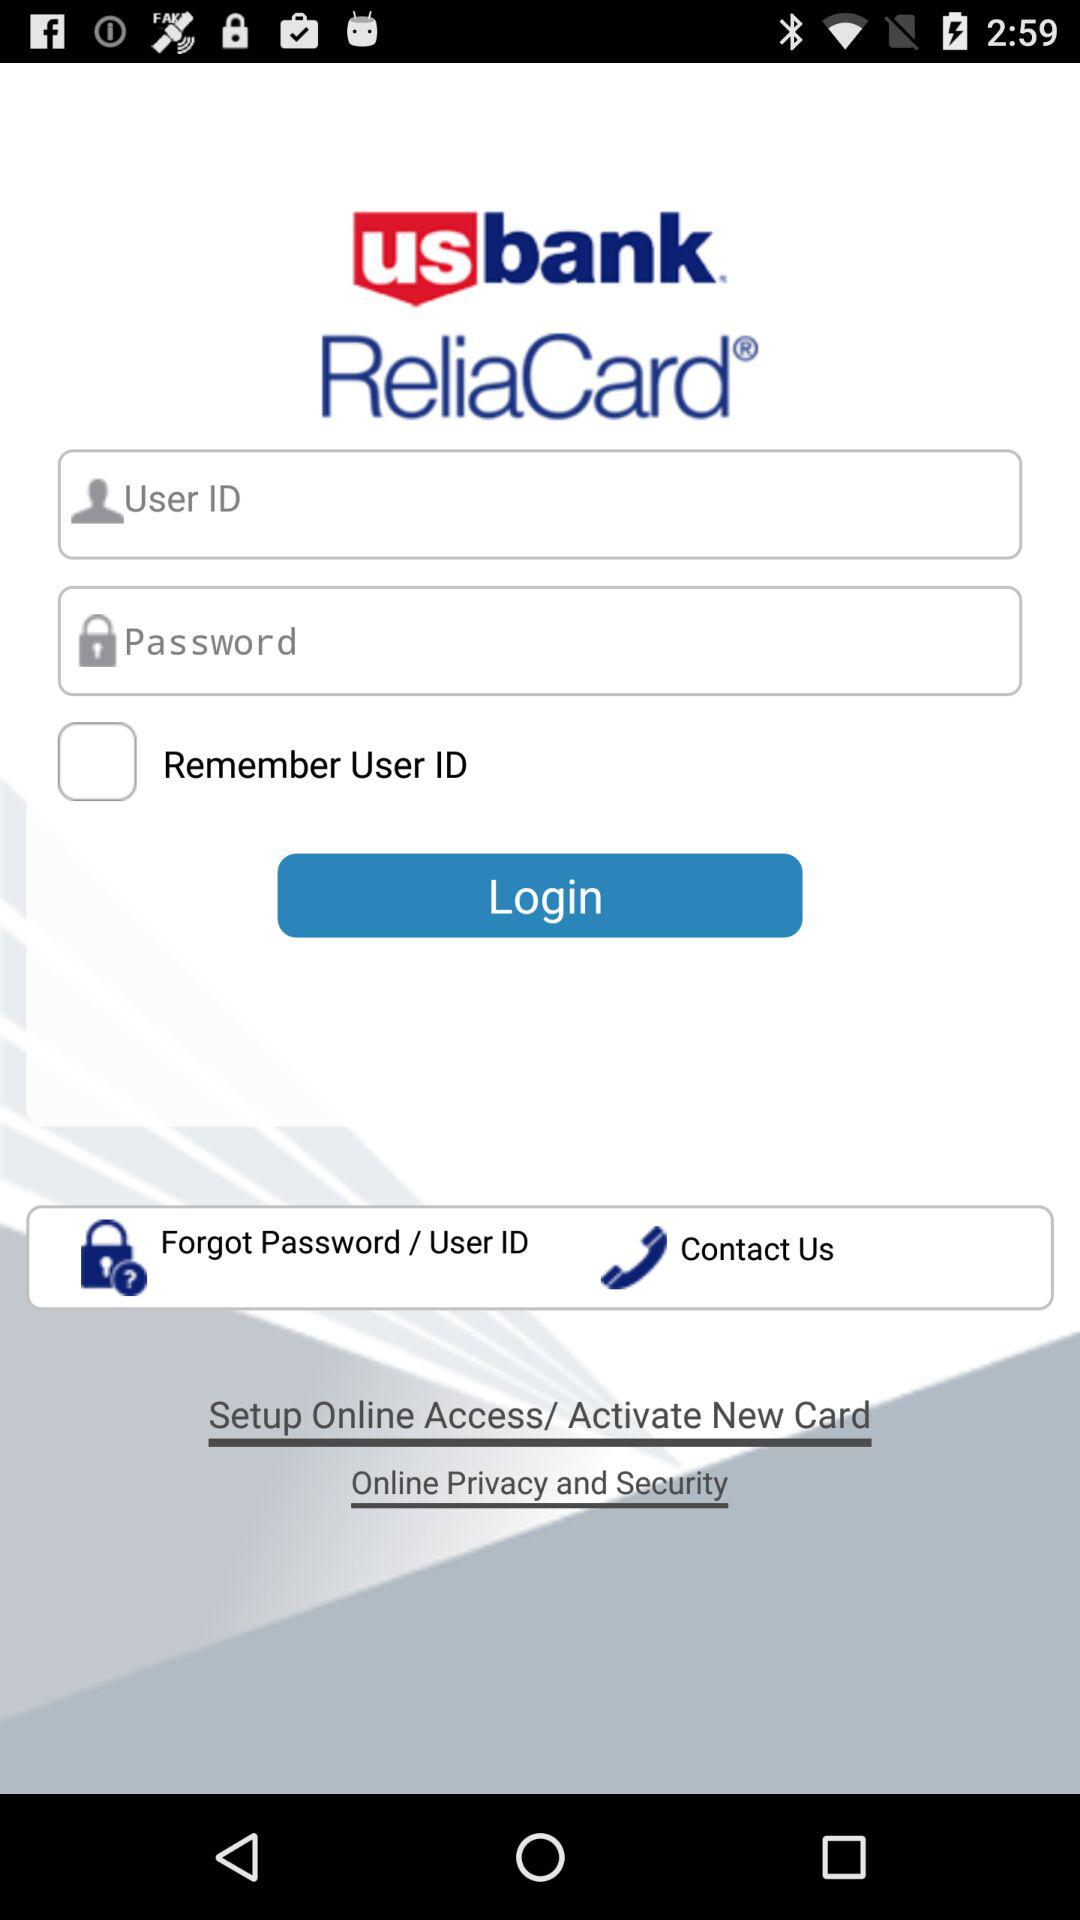What is the name of the application? The application name is "us bank ReliaCard". 